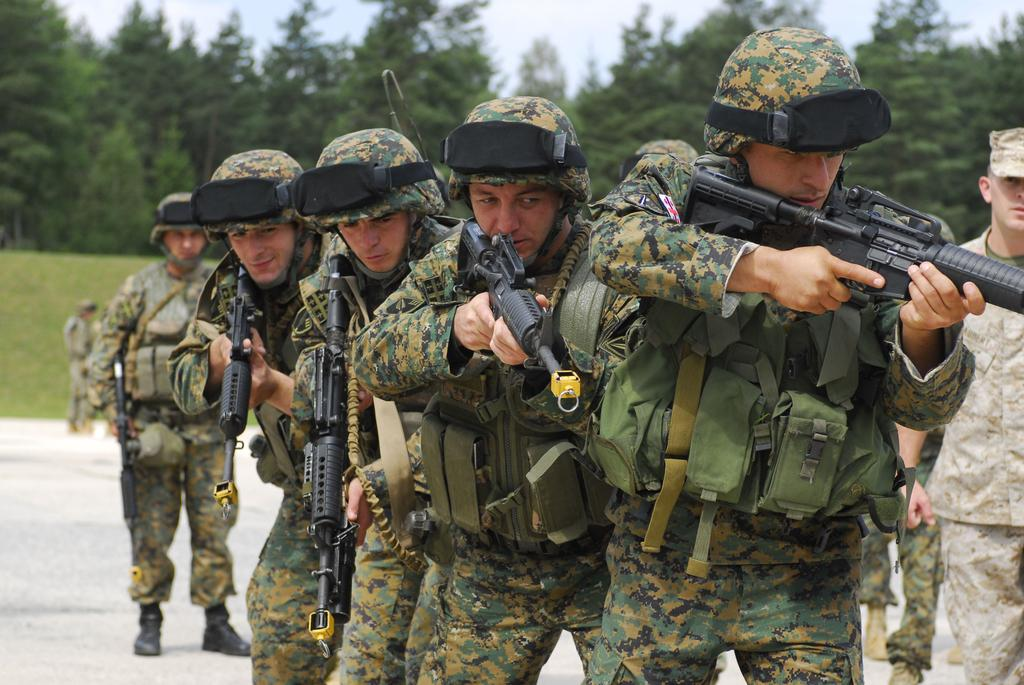What is happening in the image? There are men standing in the image, and they are holding weapons. What can be seen beneath the men's feet? There is a floor visible in the image. What is visible in the background of the image? There is ground, trees, and the sky visible in the background of the image. What level of the castle is the queen located on in the image? There is no queen present in the image, and no reference to a castle or its levels. 